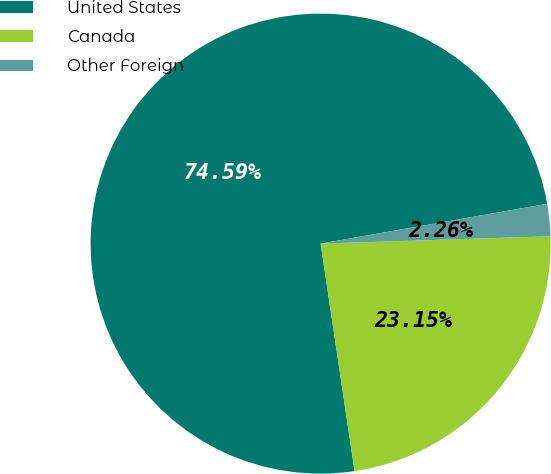<chart> <loc_0><loc_0><loc_500><loc_500><pie_chart><fcel>United States<fcel>Canada<fcel>Other Foreign<nl><fcel>74.59%<fcel>23.15%<fcel>2.26%<nl></chart> 